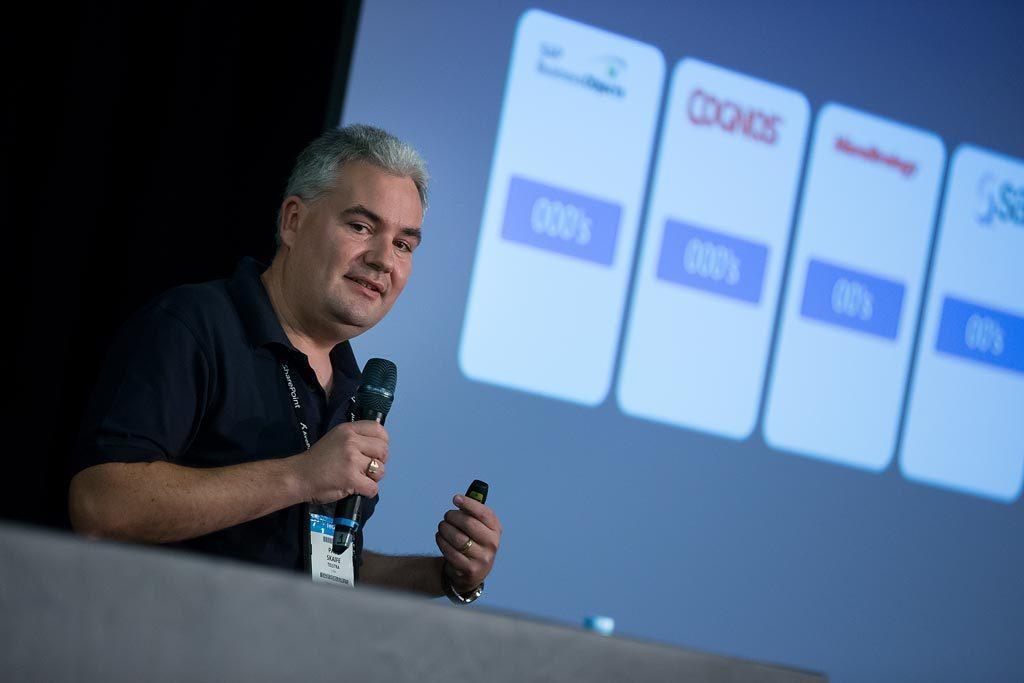Please provide a concise description of this image. In this image we can see a person holding a mic in hand and in the background, we can see a projector screen with text. 